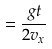<formula> <loc_0><loc_0><loc_500><loc_500>= \frac { g t } { 2 v _ { x } }</formula> 